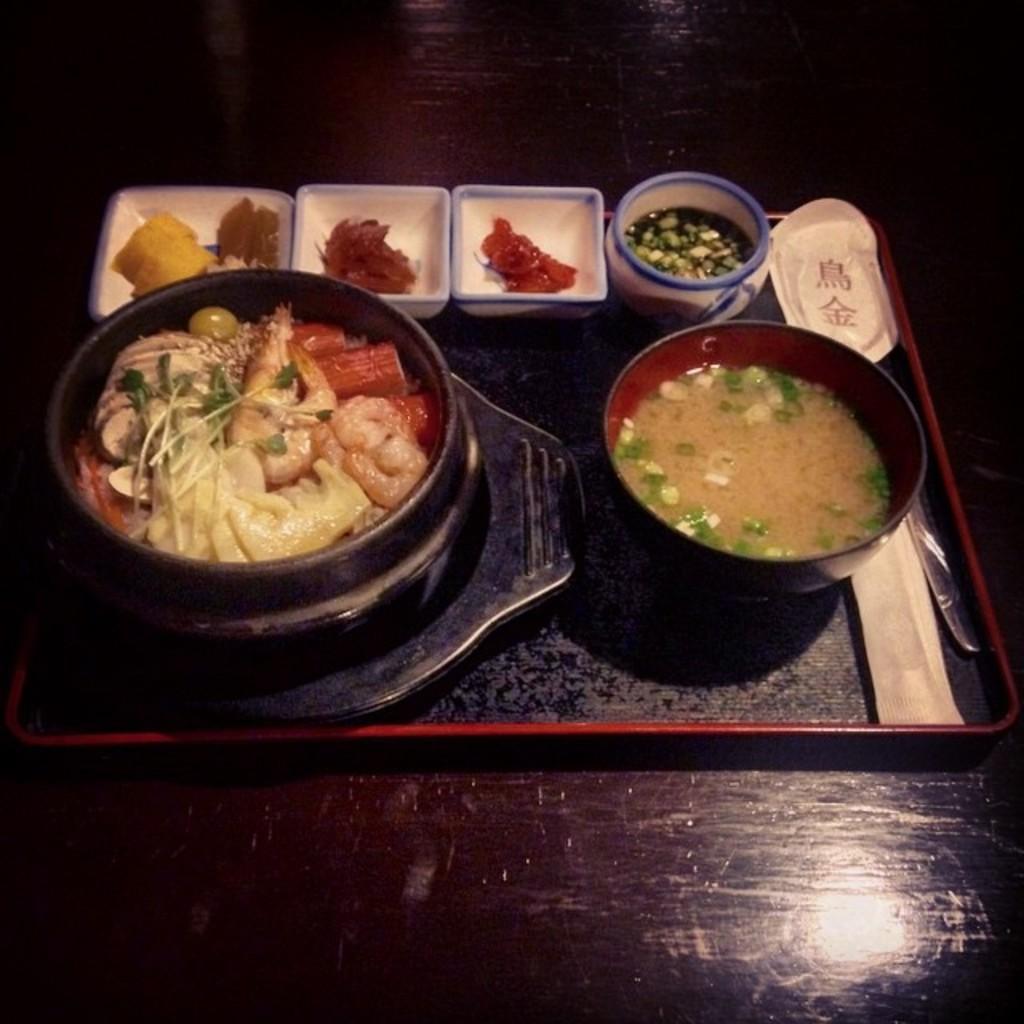Describe this image in one or two sentences. In the center of the image there are food items in bowls in a tray. At the bottom of the image there is table. 